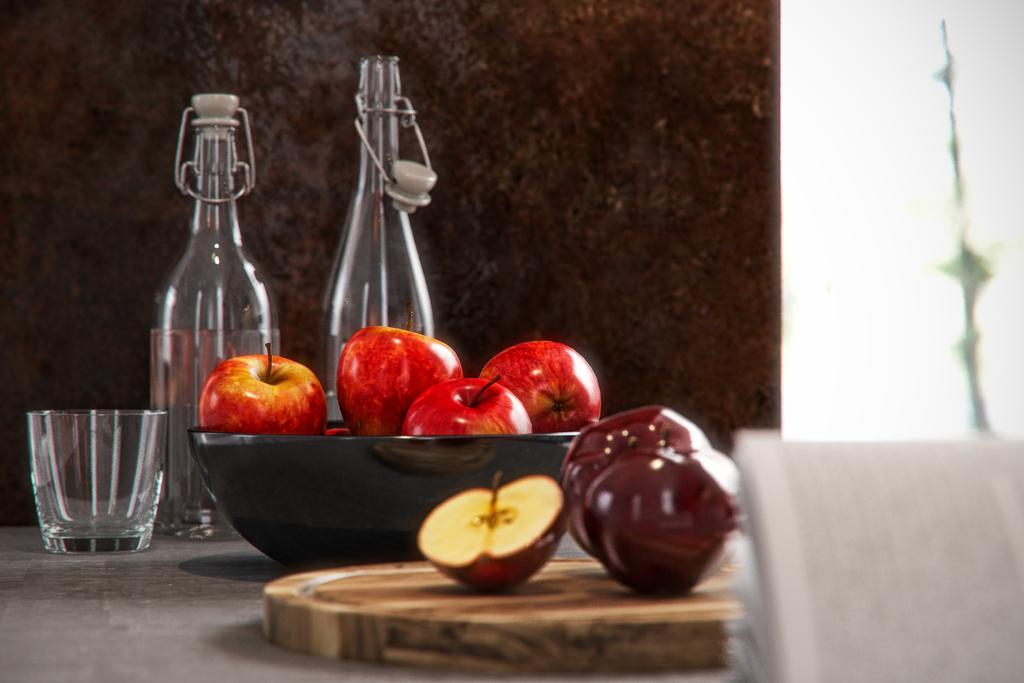What is present on the wall in the image? The facts provided do not mention any specific details about the wall. What objects can be seen on the table in the image? There is a glass bottle, a glass, and a bowl of apples on the table in the image. What is the condition of the apples in the bowl? There is a half cut apple on the bowl in the image. What type of patch can be seen on the quince in the image? There is no quince present in the image, and therefore no patch can be seen on it. What is the cook doing in the image? There is no cook present in the image, so their actions cannot be described. 